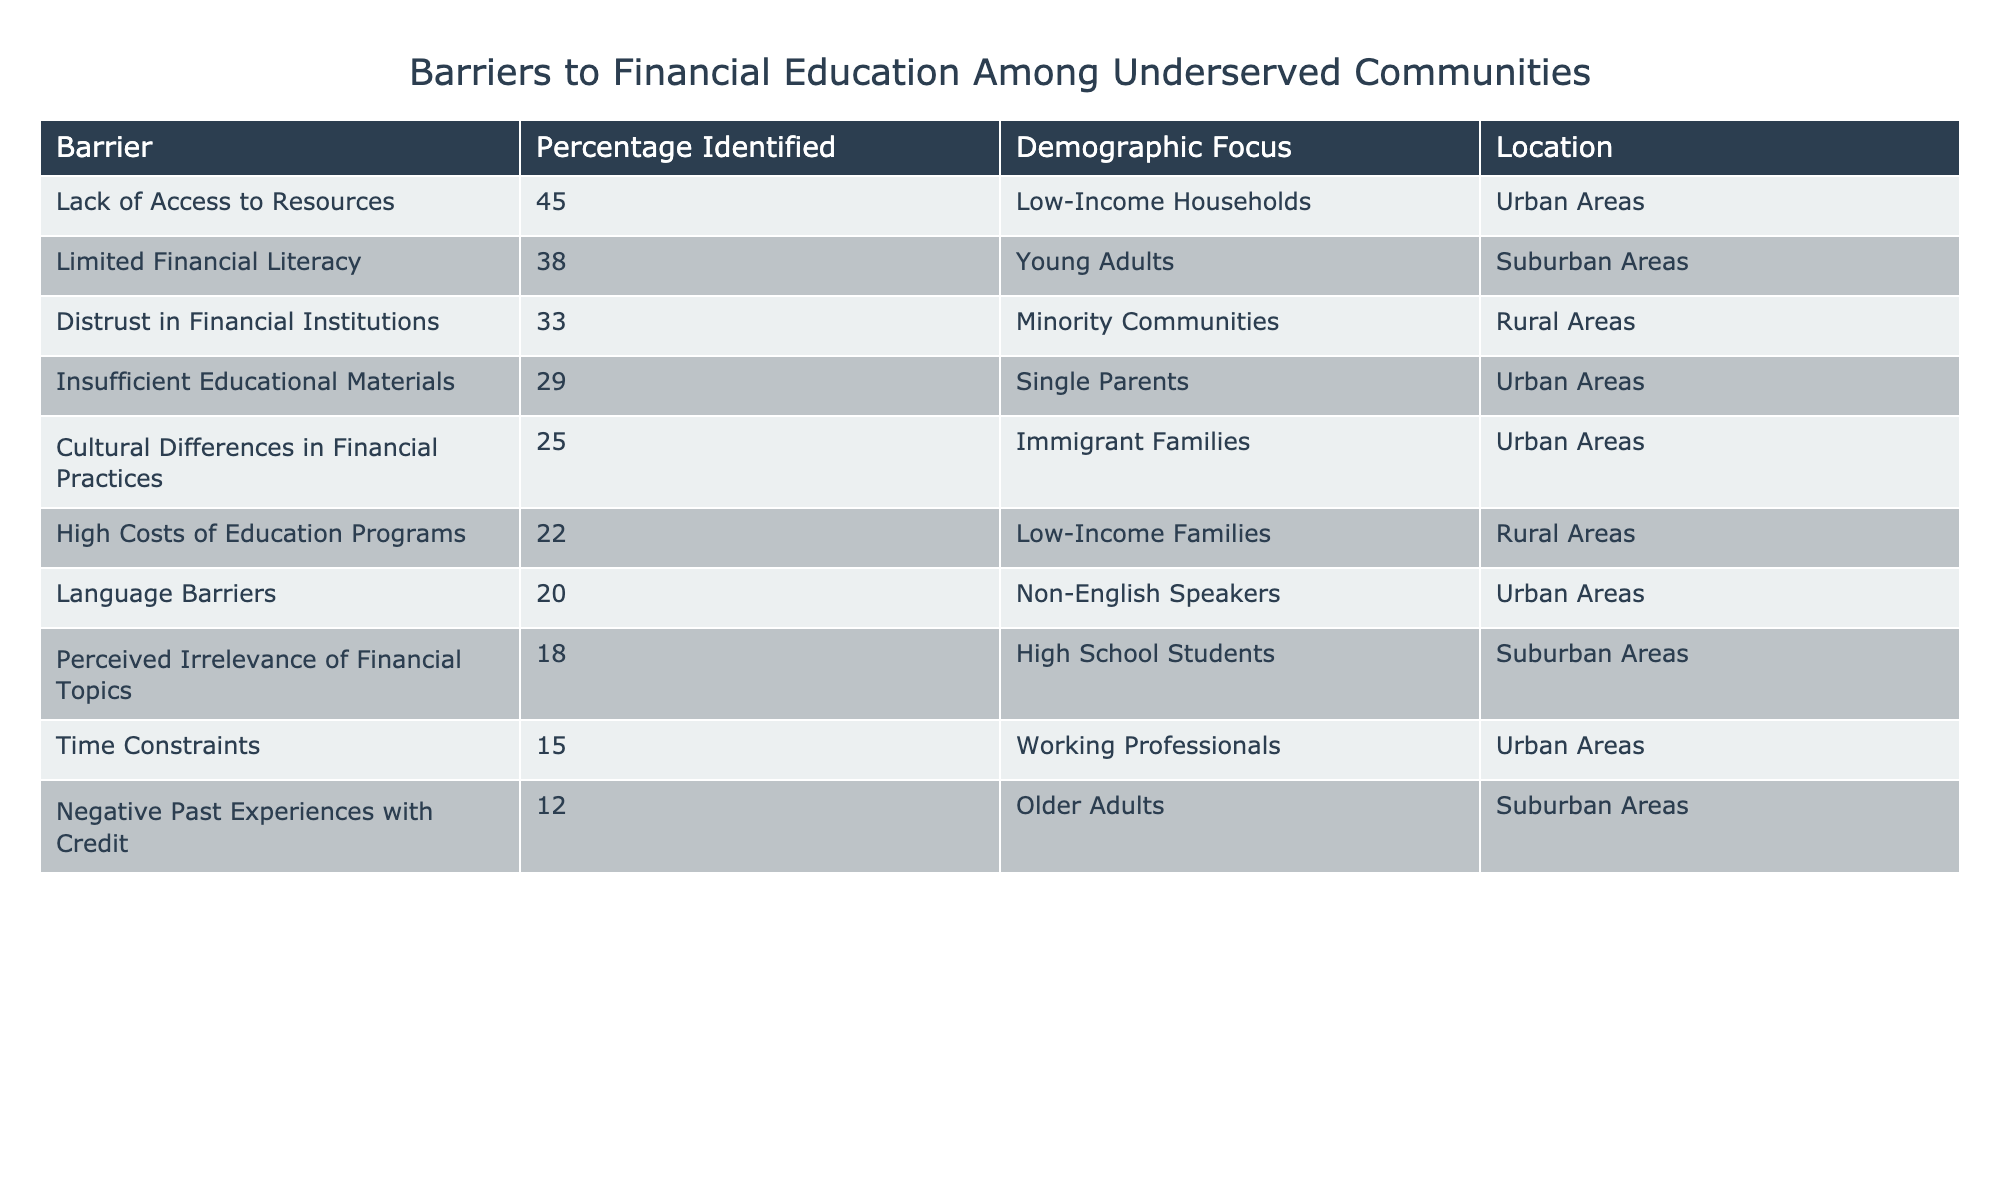What is the most identified barrier to financial education? According to the table, the highest percentage identified is "Lack of Access to Resources" at 45%.
Answer: 45% Which demographic focus has the lowest percentage identified as a barrier? The barrier with the lowest percentage identified is "Negative Past Experiences with Credit," which has 12%.
Answer: 12% What barriers are identified for Low-Income Families in Rural Areas? The table indicates that "High Costs of Education Programs" is the barrier identified for Low-Income Families in Rural Areas at 22%.
Answer: High Costs of Education Programs What is the percentage difference between the barrier of Limited Financial Literacy and Distrust in Financial Institutions? Limited Financial Literacy is identified at 38%, while Distrust in Financial Institutions is at 33%. The difference is 38% - 33% = 5%.
Answer: 5% Are there any barriers identified for Non-English Speakers in Urban Areas? Yes, the barrier identified for Non-English Speakers in Urban Areas is "Language Barriers," which is noted at 20%.
Answer: Yes What is the combined percentage of the top three barriers identified? The top three barriers are "Lack of Access to Resources" (45%), "Limited Financial Literacy" (38%), and "Distrust in Financial Institutions" (33%). Summing these gives 45% + 38% + 33% = 116%.
Answer: 116% Which demographic focus has the highest percentage identified barrier in Urban Areas? The demographic focus with the highest percentage barrier in Urban Areas is "Low-Income Households" with 45%.
Answer: Low-Income Households What percentage of the barriers is related to age, specifically for Older Adults? The barrier related to Older Adults is "Negative Past Experiences with Credit," which is identified at 12%.
Answer: 12% Which two barriers have percentages that are both under 20%? The two barriers under 20% are "Perceived Irrelevance of Financial Topics" at 18% and "Time Constraints" at 15%.
Answer: 18% and 15% If a program targets all the barriers identified for Young Adults, what percentage should it focus on? The barrier for Young Adults is "Limited Financial Literacy," which is 38%. Therefore, the program should focus on 38%.
Answer: 38% 